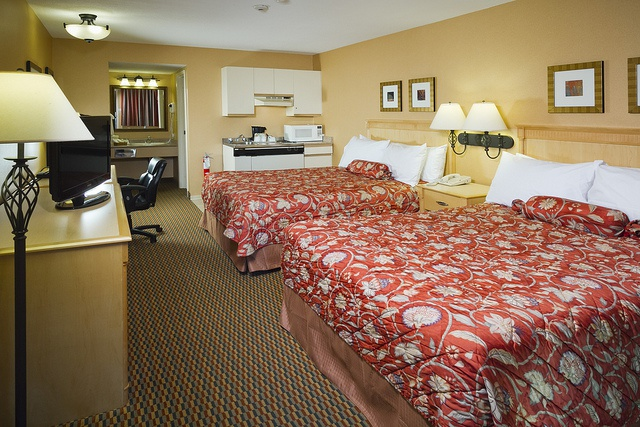Describe the objects in this image and their specific colors. I can see bed in olive, maroon, lightgray, and brown tones, bed in olive, brown, lightgray, and darkgray tones, tv in olive, black, tan, and gray tones, oven in olive, darkgray, black, and lightgray tones, and chair in olive, black, and gray tones in this image. 